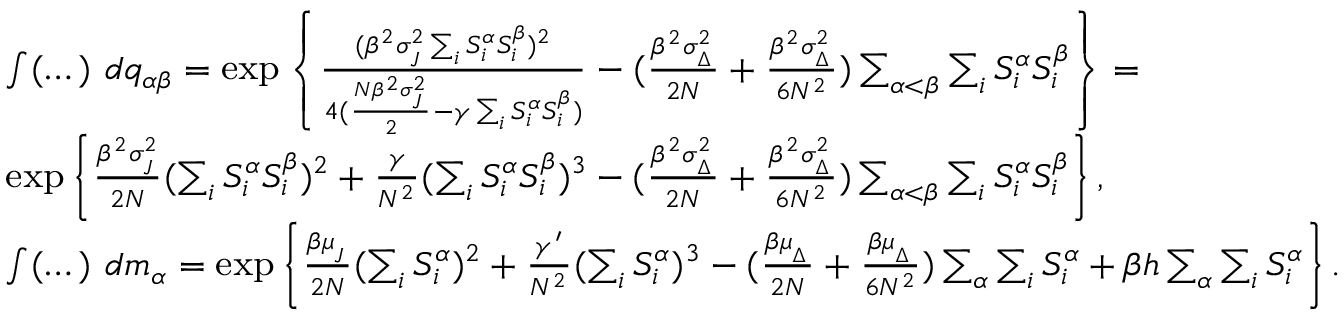<formula> <loc_0><loc_0><loc_500><loc_500>{ \begin{array} { r l } & { \int ( \dots ) \ d q _ { \alpha \beta } = \exp \left \{ \frac { ( \beta ^ { 2 } \sigma _ { _ { J } } ^ { 2 } \sum _ { i } S _ { i } ^ { \alpha } S _ { i } ^ { \beta } ) ^ { 2 } } { 4 ( \frac { N \beta ^ { 2 } \sigma _ { _ { J } } ^ { 2 } } { 2 } - \gamma \sum _ { i } S _ { i } ^ { \alpha } S _ { i } ^ { \beta } ) } - ( \frac { \beta ^ { 2 } \sigma _ { _ { \Delta } } ^ { 2 } } { 2 N } + \frac { \beta ^ { 2 } \sigma _ { _ { \Delta } } ^ { 2 } } { 6 N ^ { 2 } } ) \sum _ { \alpha < \beta } \sum _ { i } S _ { i } ^ { \alpha } S _ { i } ^ { \beta } \right \} = } \\ & { \exp \left \{ \frac { \beta ^ { 2 } \sigma _ { _ { J } } ^ { 2 } } { 2 N } ( \sum _ { i } S _ { i } ^ { \alpha } S _ { i } ^ { \beta } ) ^ { 2 } + \frac { \gamma } { N ^ { 2 } } ( \sum _ { i } S _ { i } ^ { \alpha } S _ { i } ^ { \beta } ) ^ { 3 } - ( \frac { \beta ^ { 2 } \sigma _ { _ { \Delta } } ^ { 2 } } { 2 N } + \frac { \beta ^ { 2 } \sigma _ { _ { \Delta } } ^ { 2 } } { 6 N ^ { 2 } } ) \sum _ { \alpha < \beta } \sum _ { i } S _ { i } ^ { \alpha } S _ { i } ^ { \beta } \right \} , } \\ & { \int ( \dots ) \ d m _ { \alpha } = \exp \left \{ \frac { \beta \mu _ { _ { J } } } { 2 N } ( \sum _ { i } S _ { i } ^ { \alpha } ) ^ { 2 } + \frac { \gamma ^ { \prime } } { N ^ { 2 } } ( \sum _ { i } S _ { i } ^ { \alpha } ) ^ { 3 } - ( \frac { \beta \mu _ { _ { \Delta } } } { 2 N } + \frac { \beta \mu _ { _ { \Delta } } } { 6 N ^ { 2 } } ) \sum _ { \alpha } \sum _ { i } S _ { i } ^ { \alpha } + \beta h \sum _ { \alpha } \sum _ { i } S _ { i } ^ { \alpha } \right \} . } \end{array} }</formula> 